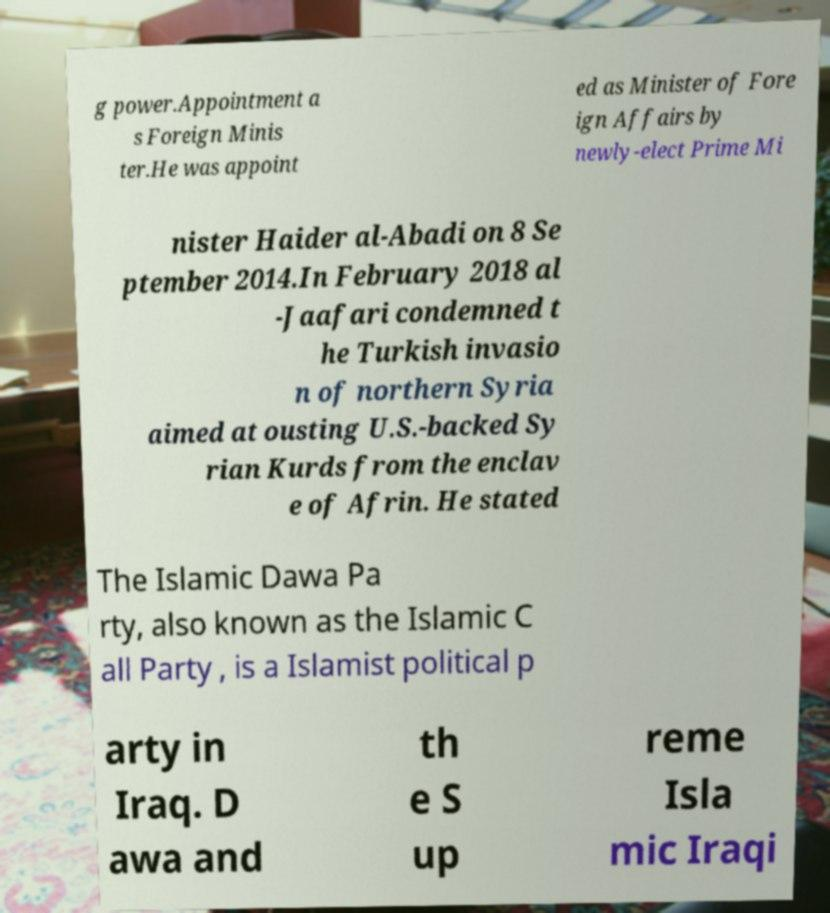Please read and relay the text visible in this image. What does it say? g power.Appointment a s Foreign Minis ter.He was appoint ed as Minister of Fore ign Affairs by newly-elect Prime Mi nister Haider al-Abadi on 8 Se ptember 2014.In February 2018 al -Jaafari condemned t he Turkish invasio n of northern Syria aimed at ousting U.S.-backed Sy rian Kurds from the enclav e of Afrin. He stated The Islamic Dawa Pa rty, also known as the Islamic C all Party , is a Islamist political p arty in Iraq. D awa and th e S up reme Isla mic Iraqi 